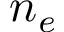<formula> <loc_0><loc_0><loc_500><loc_500>n _ { e }</formula> 